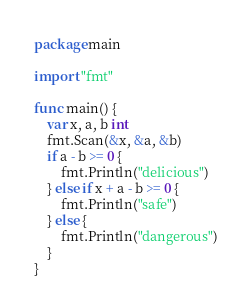<code> <loc_0><loc_0><loc_500><loc_500><_Go_>package main

import "fmt"

func main() {
	var x, a, b int
	fmt.Scan(&x, &a, &b)
	if a - b >= 0 {
		fmt.Println("delicious")
	} else if x + a - b >= 0 {
		fmt.Println("safe")
	} else {
		fmt.Println("dangerous")
	}
}</code> 